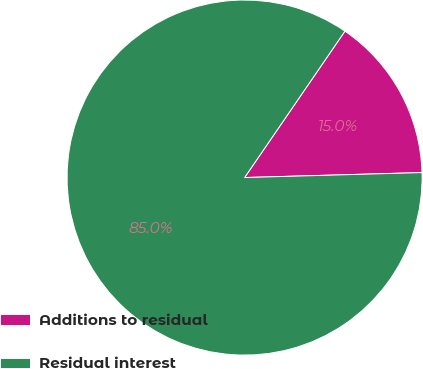Convert chart. <chart><loc_0><loc_0><loc_500><loc_500><pie_chart><fcel>Additions to residual<fcel>Residual interest<nl><fcel>14.99%<fcel>85.01%<nl></chart> 